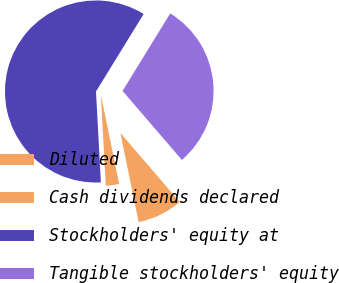<chart> <loc_0><loc_0><loc_500><loc_500><pie_chart><fcel>Diluted<fcel>Cash dividends declared<fcel>Stockholders' equity at<fcel>Tangible stockholders' equity<nl><fcel>8.09%<fcel>2.36%<fcel>59.64%<fcel>29.92%<nl></chart> 